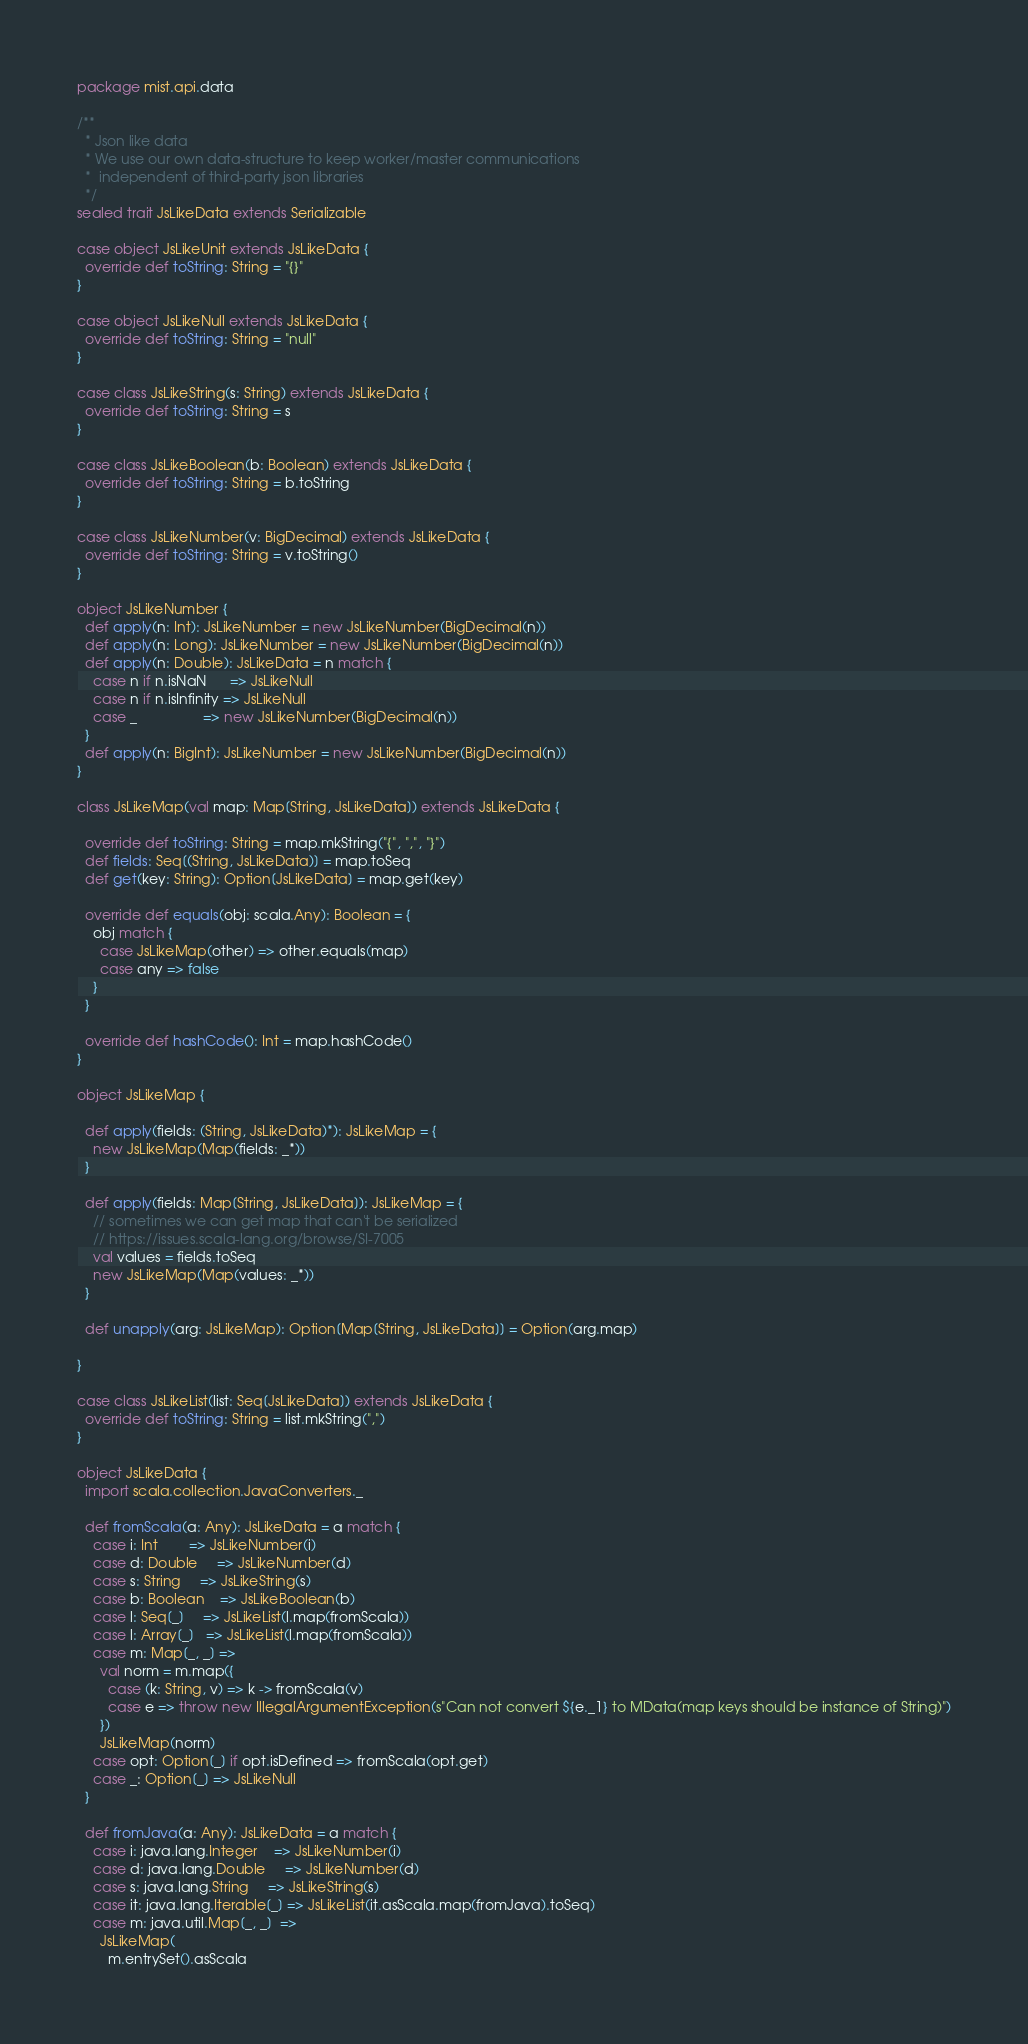<code> <loc_0><loc_0><loc_500><loc_500><_Scala_>package mist.api.data

/**
  * Json like data
  * We use our own data-structure to keep worker/master communications
  *  independent of third-party json libraries
  */
sealed trait JsLikeData extends Serializable

case object JsLikeUnit extends JsLikeData {
  override def toString: String = "{}"
}

case object JsLikeNull extends JsLikeData {
  override def toString: String = "null"
}

case class JsLikeString(s: String) extends JsLikeData {
  override def toString: String = s
}

case class JsLikeBoolean(b: Boolean) extends JsLikeData {
  override def toString: String = b.toString
}

case class JsLikeNumber(v: BigDecimal) extends JsLikeData {
  override def toString: String = v.toString()
}

object JsLikeNumber {
  def apply(n: Int): JsLikeNumber = new JsLikeNumber(BigDecimal(n))
  def apply(n: Long): JsLikeNumber = new JsLikeNumber(BigDecimal(n))
  def apply(n: Double): JsLikeData = n match {
    case n if n.isNaN      => JsLikeNull
    case n if n.isInfinity => JsLikeNull
    case _                 => new JsLikeNumber(BigDecimal(n))
  }
  def apply(n: BigInt): JsLikeNumber = new JsLikeNumber(BigDecimal(n))
}

class JsLikeMap(val map: Map[String, JsLikeData]) extends JsLikeData {

  override def toString: String = map.mkString("{", ",", "}")
  def fields: Seq[(String, JsLikeData)] = map.toSeq
  def get(key: String): Option[JsLikeData] = map.get(key)

  override def equals(obj: scala.Any): Boolean = {
    obj match {
      case JsLikeMap(other) => other.equals(map)
      case any => false
    }
  }

  override def hashCode(): Int = map.hashCode()
}

object JsLikeMap {

  def apply(fields: (String, JsLikeData)*): JsLikeMap = {
    new JsLikeMap(Map(fields: _*))
  }

  def apply(fields: Map[String, JsLikeData]): JsLikeMap = {
    // sometimes we can get map that can't be serialized
    // https://issues.scala-lang.org/browse/SI-7005
    val values = fields.toSeq
    new JsLikeMap(Map(values: _*))
  }

  def unapply(arg: JsLikeMap): Option[Map[String, JsLikeData]] = Option(arg.map)

}

case class JsLikeList(list: Seq[JsLikeData]) extends JsLikeData {
  override def toString: String = list.mkString(",")
}

object JsLikeData {
  import scala.collection.JavaConverters._

  def fromScala(a: Any): JsLikeData = a match {
    case i: Int        => JsLikeNumber(i)
    case d: Double     => JsLikeNumber(d)
    case s: String     => JsLikeString(s)
    case b: Boolean    => JsLikeBoolean(b)
    case l: Seq[_]     => JsLikeList(l.map(fromScala))
    case l: Array[_]   => JsLikeList(l.map(fromScala))
    case m: Map[_, _] =>
      val norm = m.map({
        case (k: String, v) => k -> fromScala(v)
        case e => throw new IllegalArgumentException(s"Can not convert ${e._1} to MData(map keys should be instance of String)")
      })
      JsLikeMap(norm)
    case opt: Option[_] if opt.isDefined => fromScala(opt.get)
    case _: Option[_] => JsLikeNull
  }

  def fromJava(a: Any): JsLikeData = a match {
    case i: java.lang.Integer    => JsLikeNumber(i)
    case d: java.lang.Double     => JsLikeNumber(d)
    case s: java.lang.String     => JsLikeString(s)
    case it: java.lang.Iterable[_] => JsLikeList(it.asScala.map(fromJava).toSeq)
    case m: java.util.Map[_, _]  =>
      JsLikeMap(
        m.entrySet().asScala</code> 